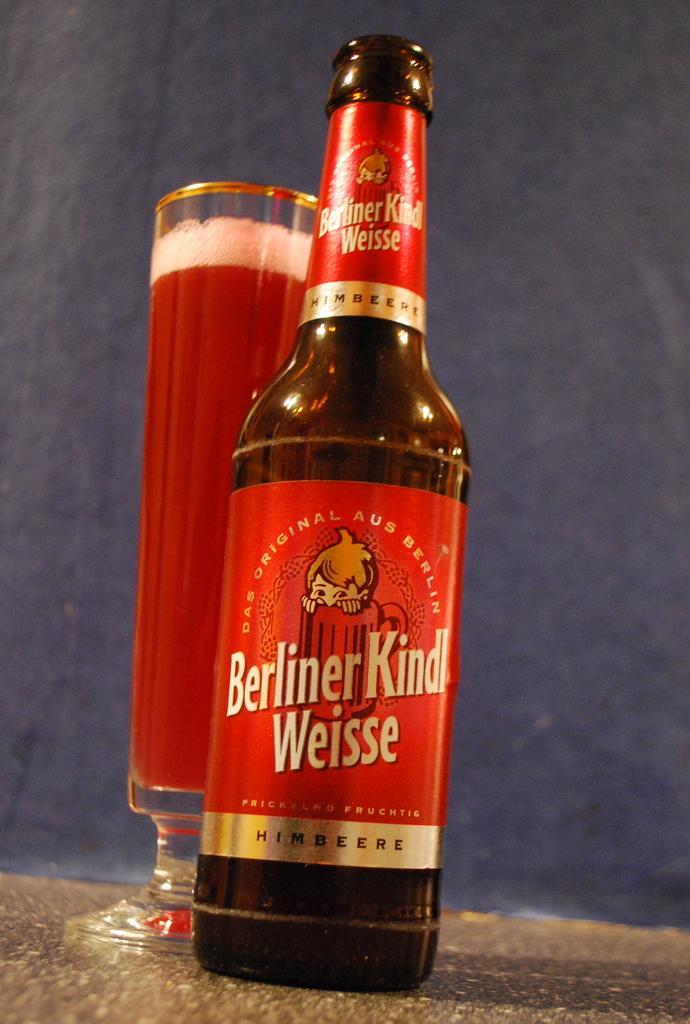In one or two sentences, can you explain what this image depicts? In this picture there is a glass bottle and there is a glass of drink beside it. 